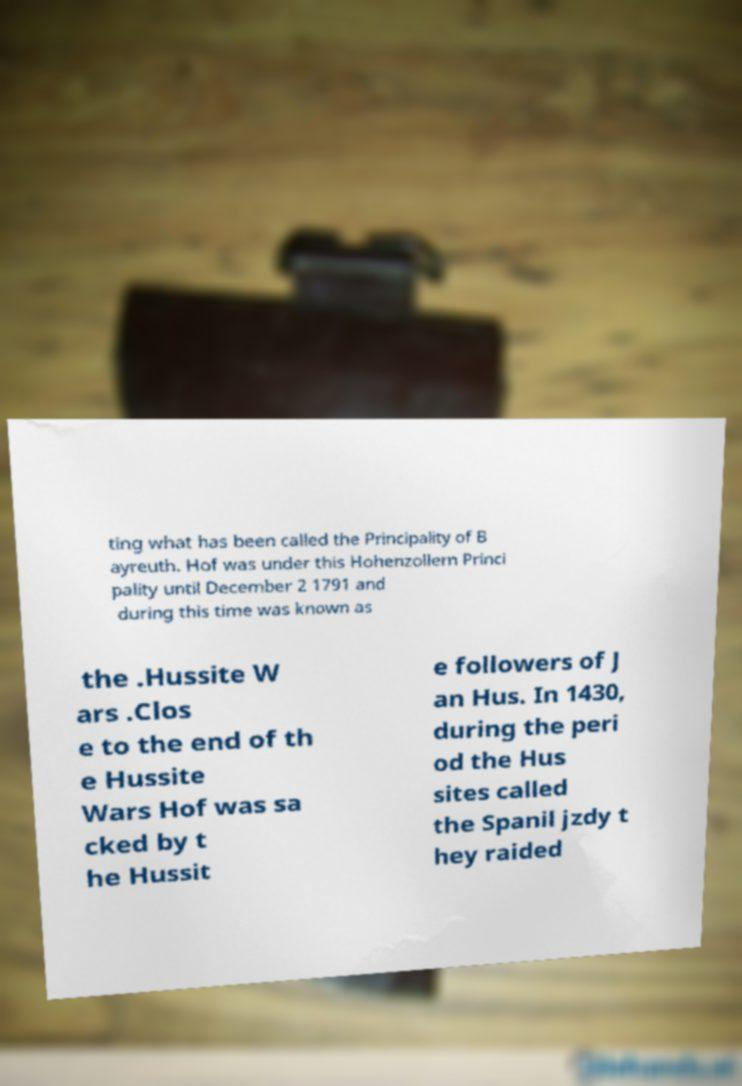What messages or text are displayed in this image? I need them in a readable, typed format. ting what has been called the Principality of B ayreuth. Hof was under this Hohenzollern Princi pality until December 2 1791 and during this time was known as the .Hussite W ars .Clos e to the end of th e Hussite Wars Hof was sa cked by t he Hussit e followers of J an Hus. In 1430, during the peri od the Hus sites called the Spanil jzdy t hey raided 